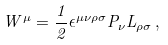<formula> <loc_0><loc_0><loc_500><loc_500>W ^ { \mu } = \frac { 1 } { 2 } \epsilon ^ { \mu \nu \rho \sigma } P _ { \nu } L _ { \rho \sigma } \, ,</formula> 